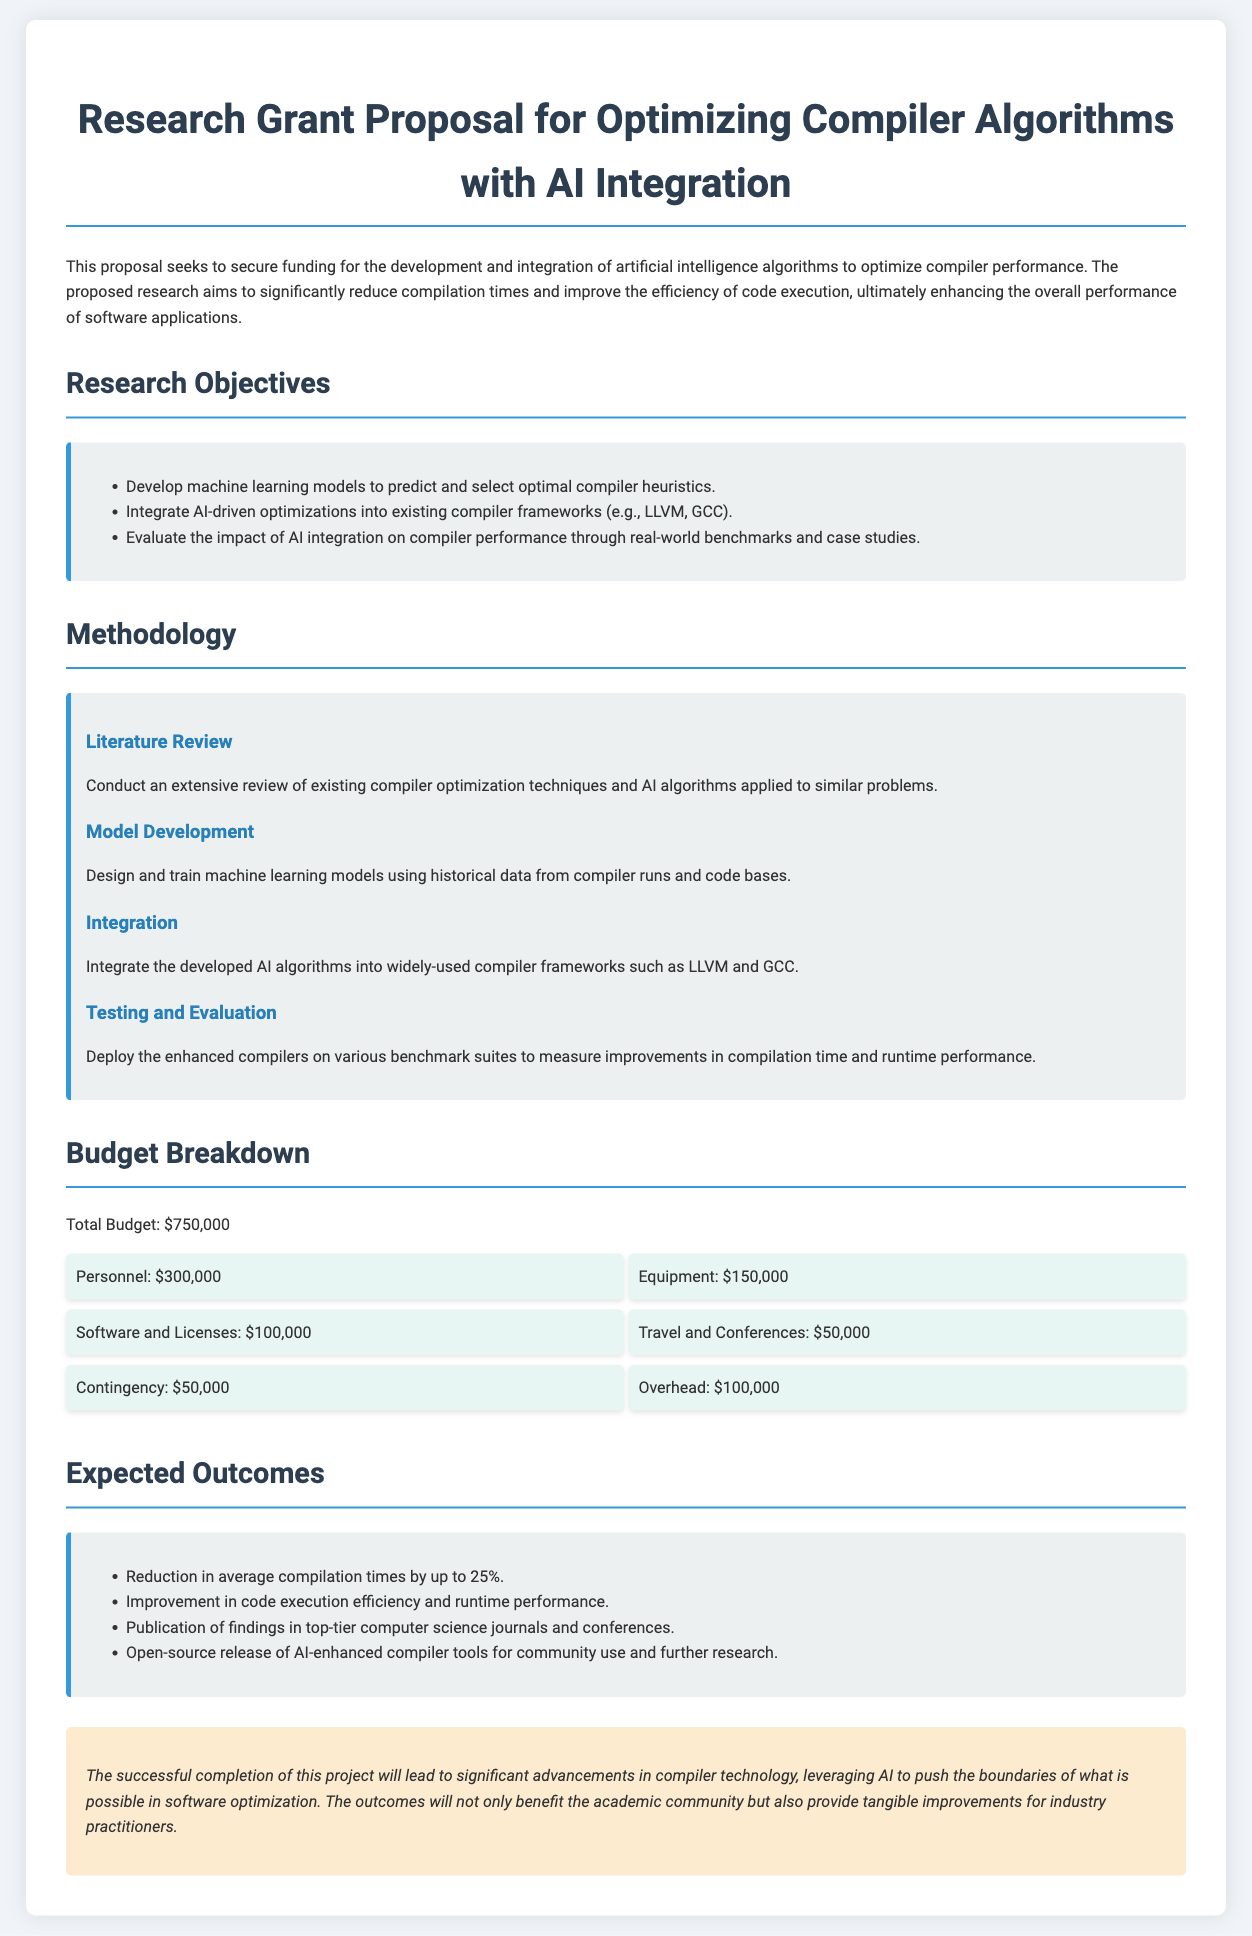What is the title of the proposal? The title refers to the subject of the research project, highlighted at the beginning of the document.
Answer: Research Grant Proposal for Optimizing Compiler Algorithms with AI Integration What is the total budget for the project? The total budget is explicitly stated in the budget breakdown section of the document.
Answer: $750,000 What are the first two research objectives listed? The research objectives are listed in a bullet format, with the first two objectives clearly mentioned.
Answer: Develop machine learning models to predict and select optimal compiler heuristics; Integrate AI-driven optimizations into existing compiler frameworks (e.g., LLVM, GCC) Which compiler frameworks are mentioned for integration? The document specifies the frameworks where the AI-driven optimizations will be integrated, thus directly answering the question.
Answer: LLVM, GCC What is one expected outcome of the research? Expected outcomes are listed in a bullet format; any of them can serve as a valid answer to this question.
Answer: Reduction in average compilation times by up to 25% How many steps are included in the methodology section? The methodology section outlines specific steps, the count of which can be determined by listing them.
Answer: Four What is the budget amount allocated for equipment? The budget breakdown includes specified amounts for different categories, including equipment, allowing a straightforward retrieval of this information.
Answer: $150,000 What type of release is expected for the AI-enhanced compiler tools? The expected outcomes section discusses the release type, which indicates how the project's products will be shared.
Answer: Open-source release 